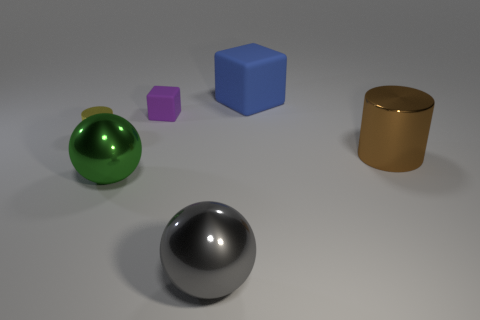Is there any object that reflects light more than the others? Indeed, the sphere in the front, with its silvery and polished surface, reflects light significantly more than the other objects. 